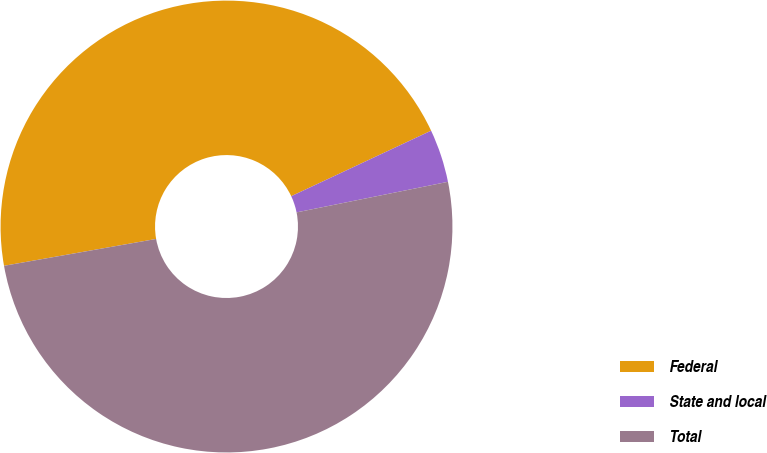Convert chart. <chart><loc_0><loc_0><loc_500><loc_500><pie_chart><fcel>Federal<fcel>State and local<fcel>Total<nl><fcel>45.81%<fcel>3.8%<fcel>50.39%<nl></chart> 